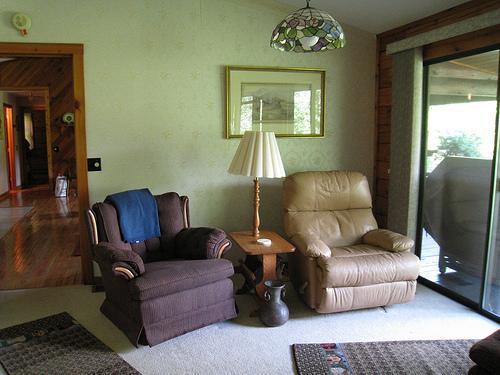How many chairs have blue blankets on them?
Give a very brief answer. 1. 